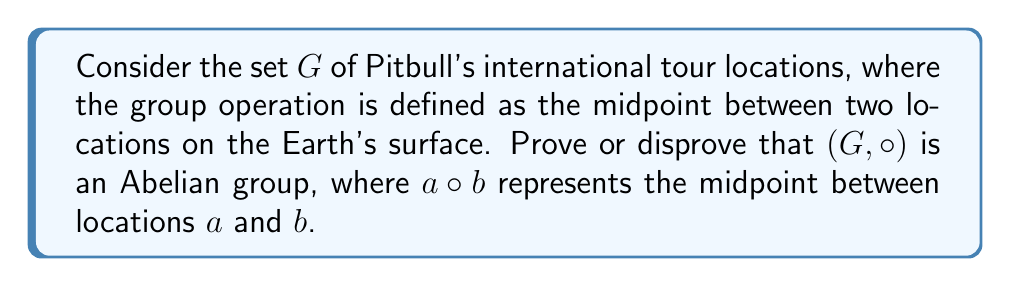Teach me how to tackle this problem. To prove whether the group $(G, \circ)$ is Abelian, we need to check if the operation is commutative for all elements in $G$. Let's approach this step-by-step:

1) First, we need to verify if $(G, \circ)$ is indeed a group:
   - Closure: The midpoint between any two locations on Earth is always another point on Earth, so $G$ is closed under $\circ$.
   - Associativity: $(a \circ b) \circ c = a \circ (b \circ c)$ for all $a, b, c \in G$, as the midpoint operation is geometrically associative.
   - Identity: The identity element would be a point that, when combined with any other point, gives that other point. No such point exists on Earth's surface.
   - Inverse: For any point $a$, there's no point $b$ such that $a \circ b$ gives the identity (which doesn't exist anyway).

2) Since $(G, \circ)$ lacks an identity element and inverses, it is not a group. Therefore, it cannot be an Abelian group.

3) However, we can still check if the operation is commutative:
   Let $a = (lat_1, lon_1)$ and $b = (lat_2, lon_2)$ be two locations.
   
   $a \circ b = (\frac{lat_1 + lat_2}{2}, \frac{lon_1 + lon_2}{2})$
   $b \circ a = (\frac{lat_2 + lat_1}{2}, \frac{lon_2 + lon_1}{2})$

   Clearly, $a \circ b = b \circ a$ for all $a, b \in G$.

4) While the operation is commutative, the lack of group properties prevents $(G, \circ)$ from being an Abelian group.
Answer: $(G, \circ)$ is not an Abelian group because it is not a group. The operation lacks an identity element and inverses. However, the operation is commutative. 